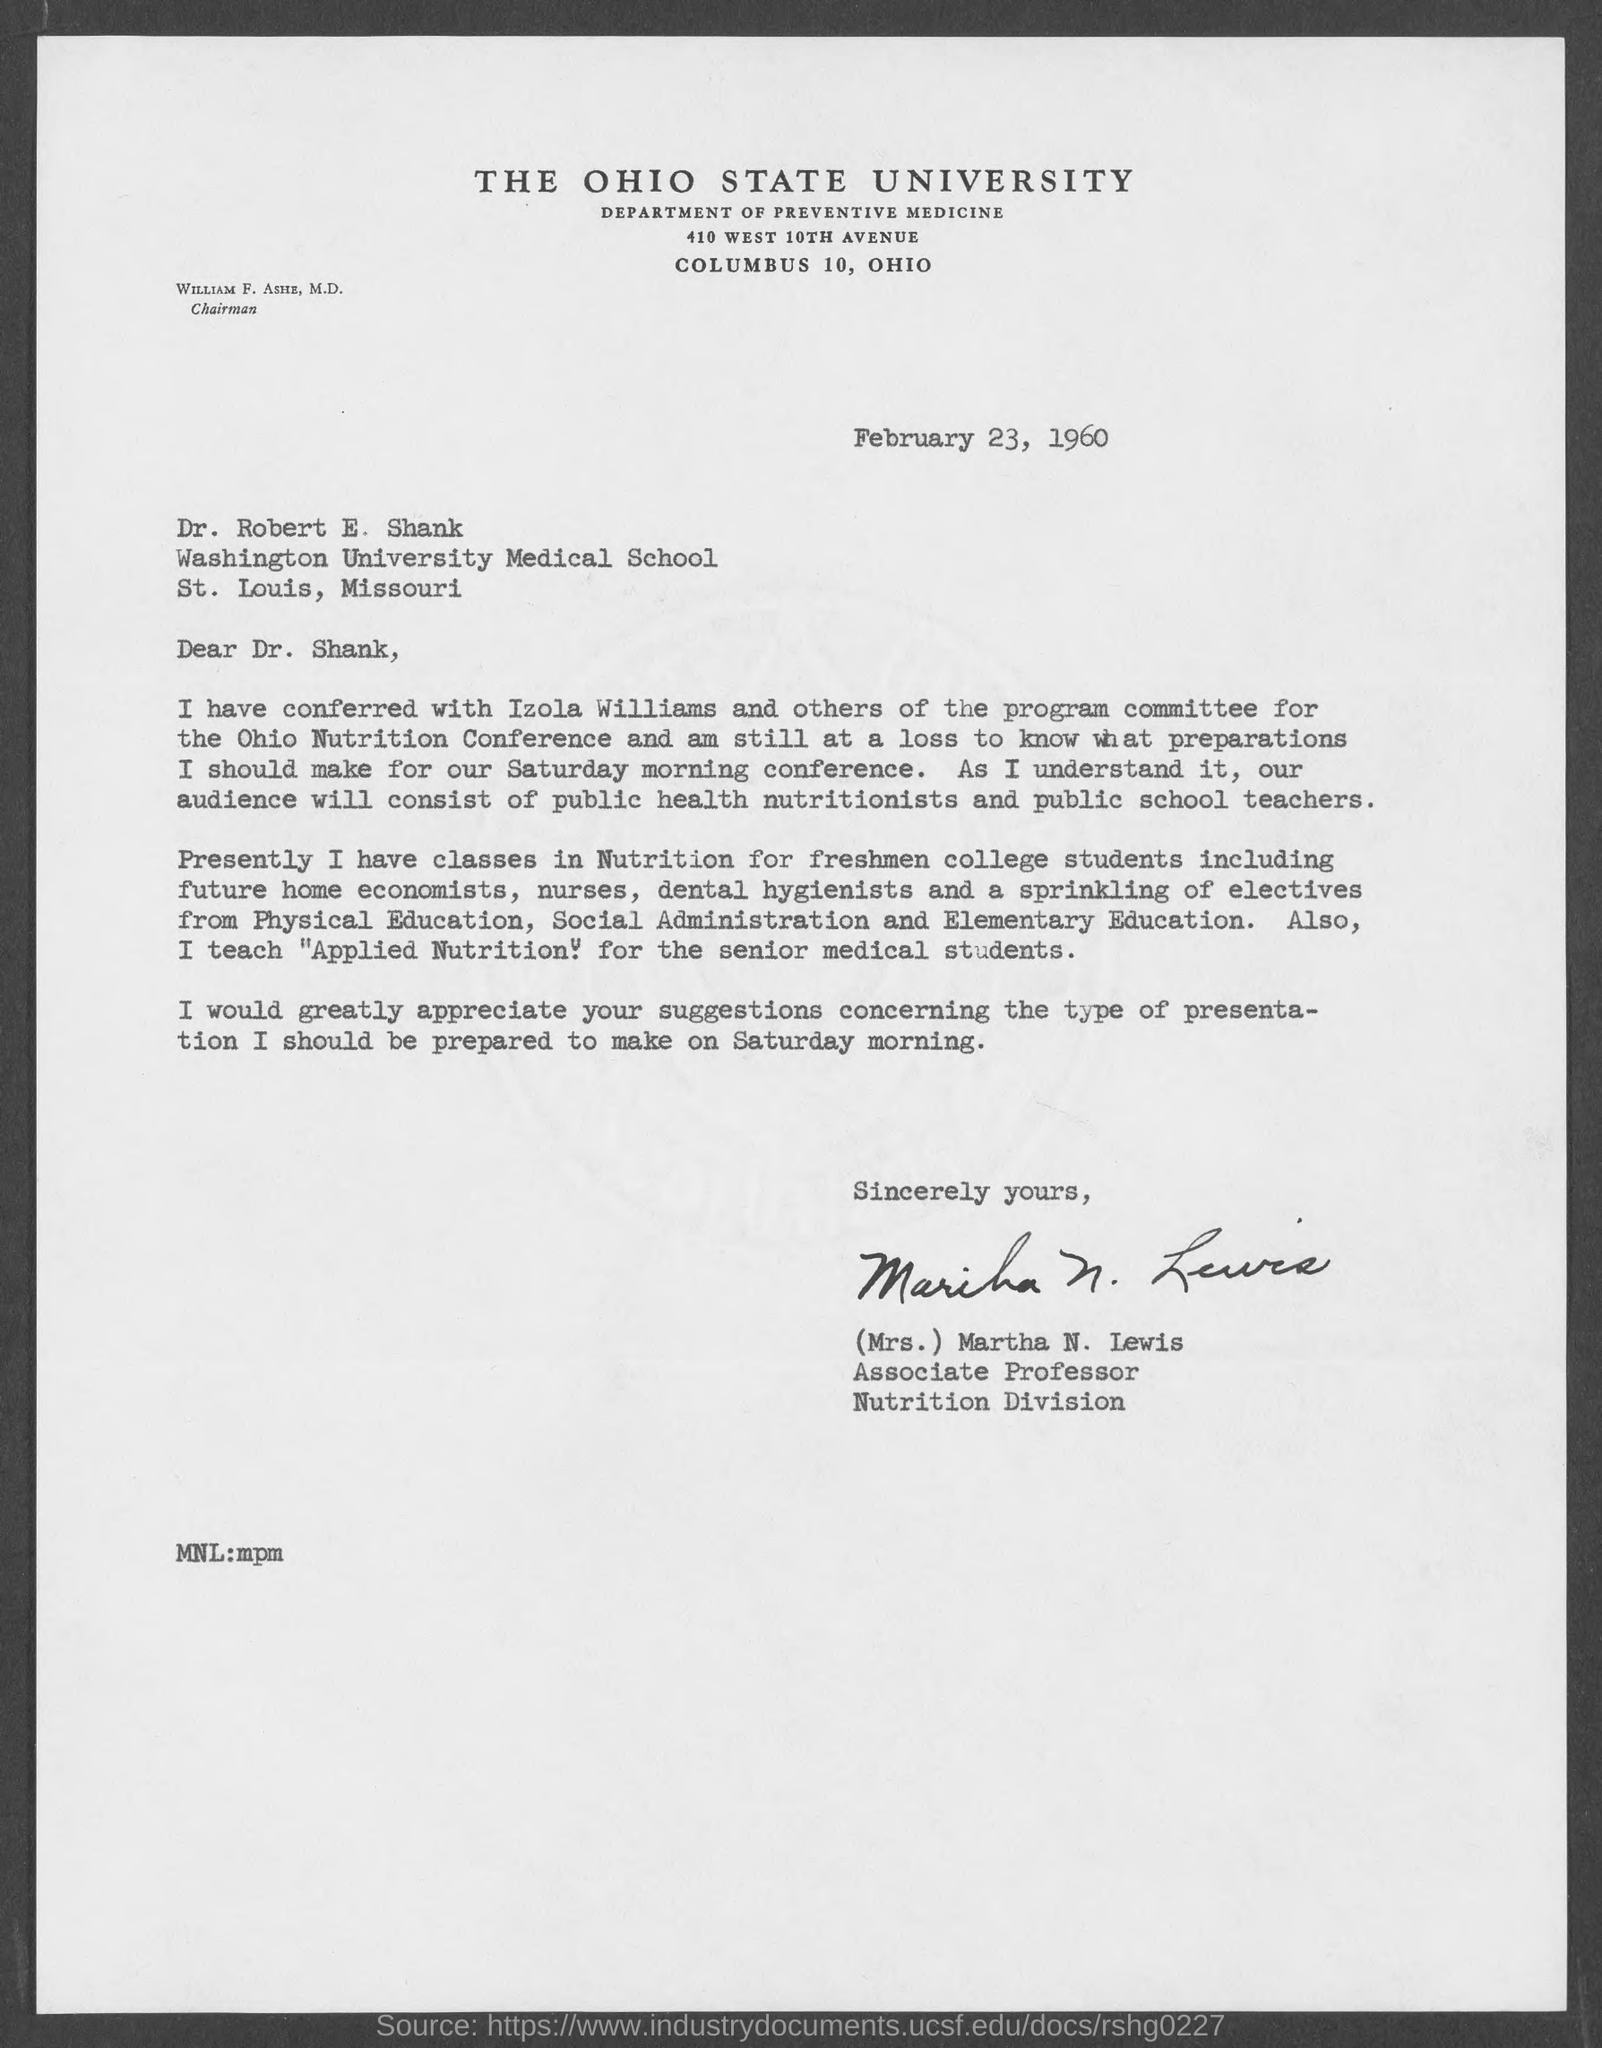Outline some significant characteristics in this image. The memorandum is addressed to Dr. Robert E. Shank. 